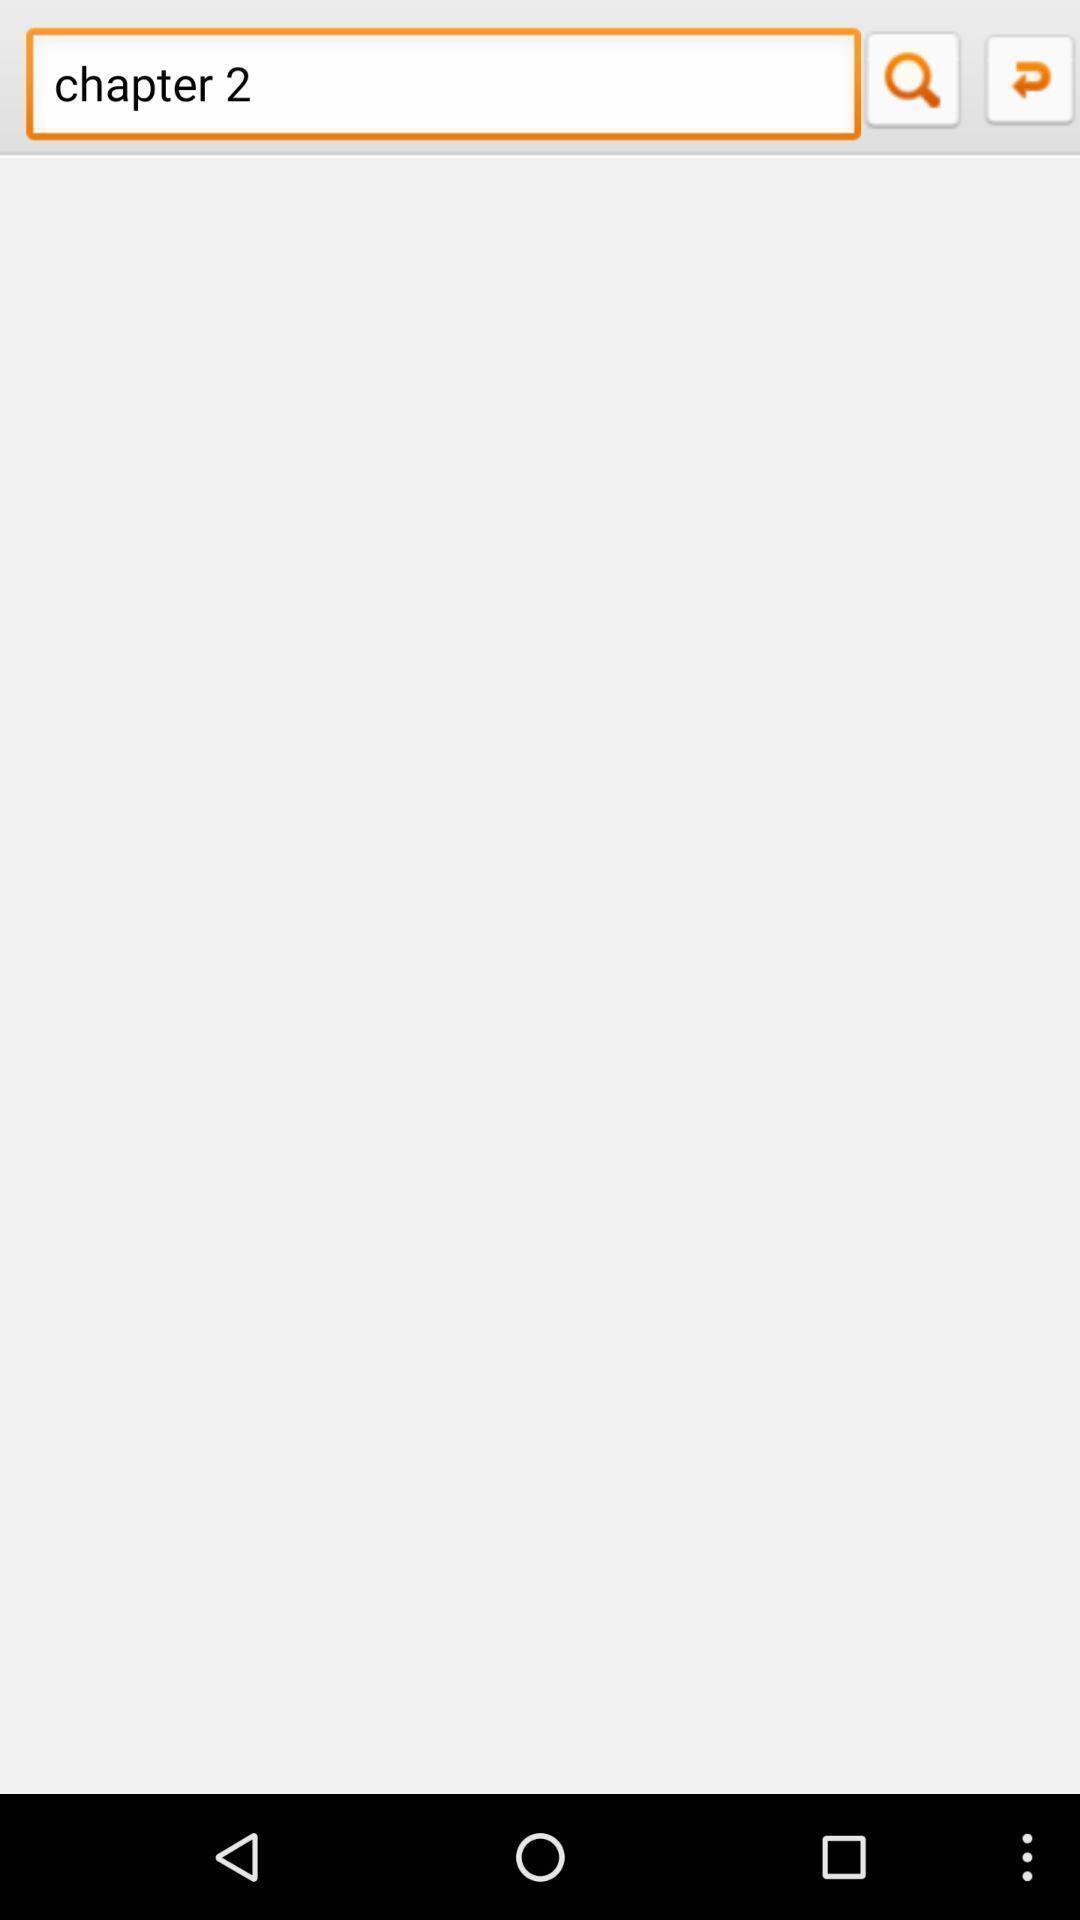Describe this image in words. Search box displaying. 